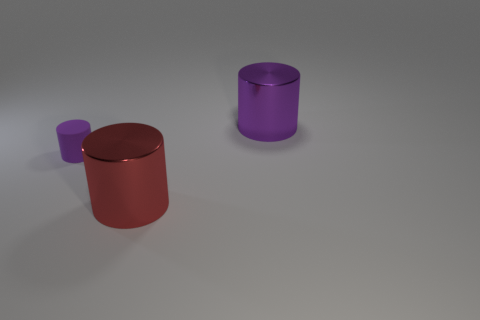Add 3 small cyan objects. How many objects exist? 6 Add 2 small objects. How many small objects are left? 3 Add 3 large purple metallic objects. How many large purple metallic objects exist? 4 Subtract 0 brown cylinders. How many objects are left? 3 Subtract all small purple matte cylinders. Subtract all large red cylinders. How many objects are left? 1 